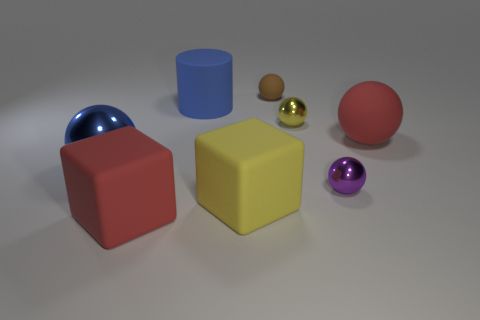Subtract 2 spheres. How many spheres are left? 3 Subtract all large metal balls. How many balls are left? 4 Subtract all cyan spheres. Subtract all cyan blocks. How many spheres are left? 5 Add 2 brown blocks. How many objects exist? 10 Subtract all balls. How many objects are left? 3 Subtract 0 brown blocks. How many objects are left? 8 Subtract all brown rubber cubes. Subtract all small yellow shiny balls. How many objects are left? 7 Add 2 purple metal balls. How many purple metal balls are left? 3 Add 4 red rubber balls. How many red rubber balls exist? 5 